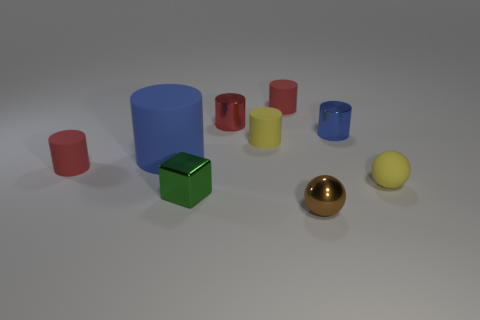Subtract all tiny red metallic cylinders. How many cylinders are left? 5 Subtract all red blocks. How many blue cylinders are left? 2 Subtract all blue cylinders. How many cylinders are left? 4 Subtract 3 cylinders. How many cylinders are left? 3 Subtract all blocks. How many objects are left? 8 Subtract all small green metallic cubes. Subtract all large yellow metal things. How many objects are left? 8 Add 8 red matte things. How many red matte things are left? 10 Add 5 small red metal cylinders. How many small red metal cylinders exist? 6 Subtract 0 red balls. How many objects are left? 9 Subtract all purple cubes. Subtract all purple cylinders. How many cubes are left? 1 